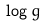<formula> <loc_0><loc_0><loc_500><loc_500>\log g</formula> 